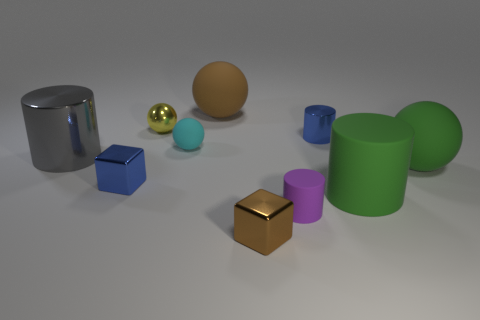Subtract all small metal spheres. How many spheres are left? 3 Subtract all blue blocks. How many blocks are left? 1 Subtract all cubes. How many objects are left? 8 Subtract 2 cylinders. How many cylinders are left? 2 Subtract 1 gray cylinders. How many objects are left? 9 Subtract all brown cylinders. Subtract all yellow blocks. How many cylinders are left? 4 Subtract all brown cylinders. How many blue blocks are left? 1 Subtract all small metal blocks. Subtract all cyan spheres. How many objects are left? 7 Add 9 yellow objects. How many yellow objects are left? 10 Add 3 tiny metal spheres. How many tiny metal spheres exist? 4 